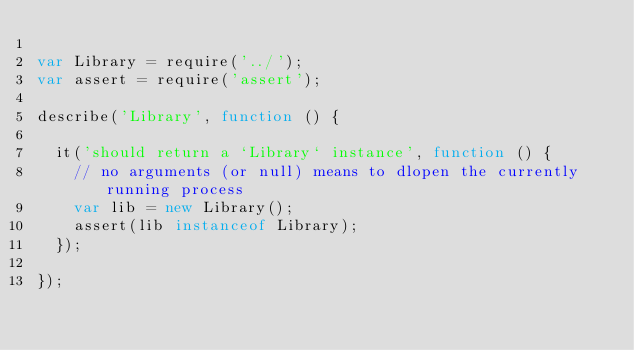<code> <loc_0><loc_0><loc_500><loc_500><_JavaScript_>
var Library = require('../');
var assert = require('assert');

describe('Library', function () {

  it('should return a `Library` instance', function () {
    // no arguments (or null) means to dlopen the currently running process
    var lib = new Library();
    assert(lib instanceof Library);
  });

});
</code> 